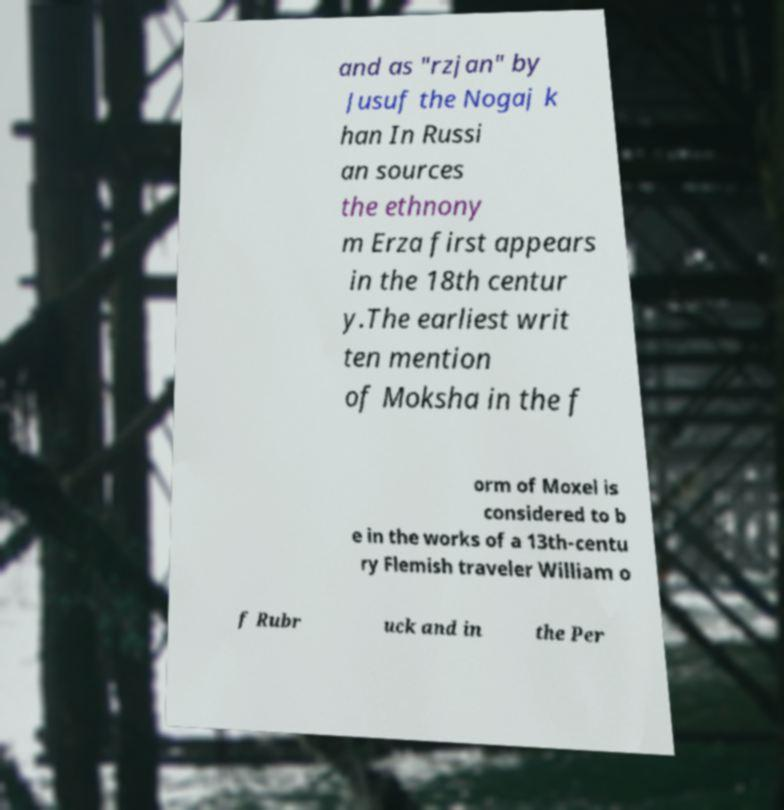Could you assist in decoding the text presented in this image and type it out clearly? and as "rzjan" by Jusuf the Nogaj k han In Russi an sources the ethnony m Erza first appears in the 18th centur y.The earliest writ ten mention of Moksha in the f orm of Moxel is considered to b e in the works of a 13th-centu ry Flemish traveler William o f Rubr uck and in the Per 